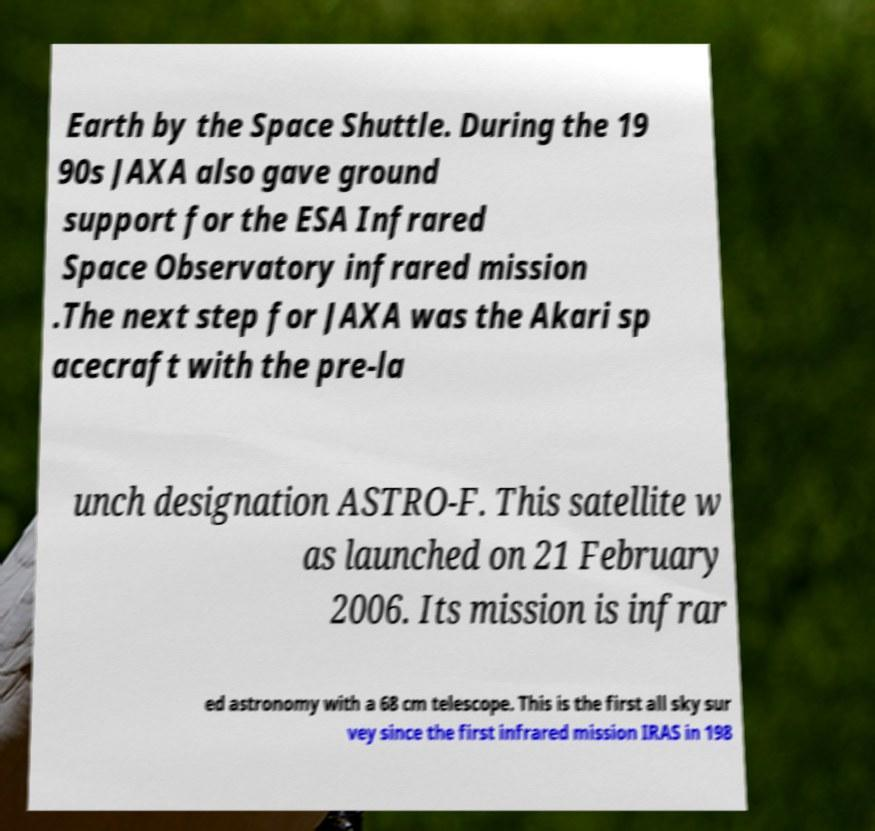Can you read and provide the text displayed in the image?This photo seems to have some interesting text. Can you extract and type it out for me? Earth by the Space Shuttle. During the 19 90s JAXA also gave ground support for the ESA Infrared Space Observatory infrared mission .The next step for JAXA was the Akari sp acecraft with the pre-la unch designation ASTRO-F. This satellite w as launched on 21 February 2006. Its mission is infrar ed astronomy with a 68 cm telescope. This is the first all sky sur vey since the first infrared mission IRAS in 198 